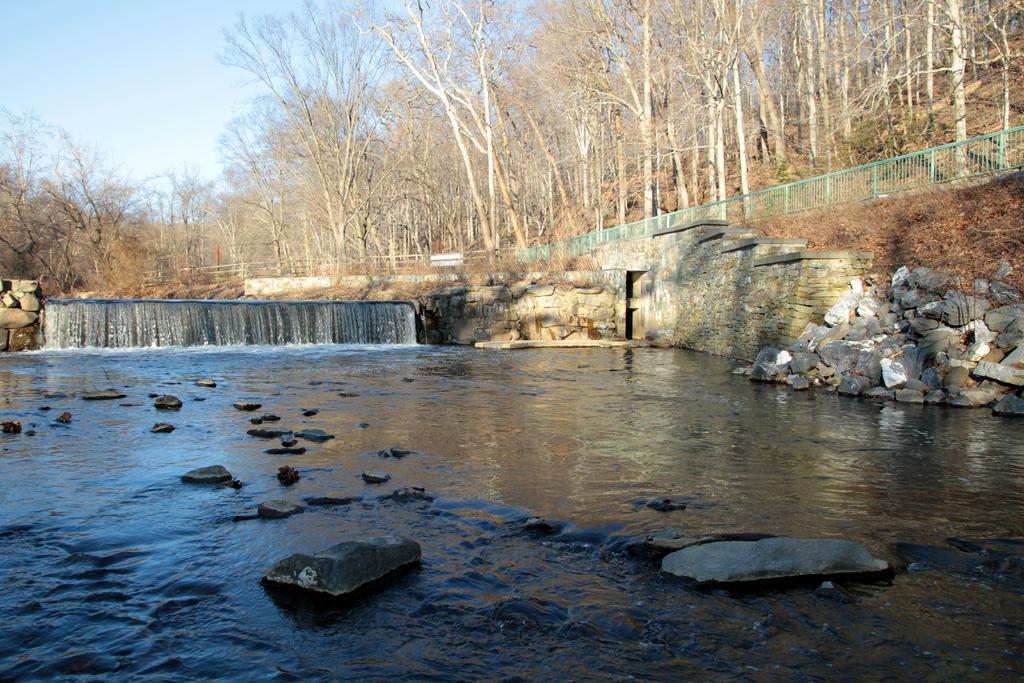In one or two sentences, can you explain what this image depicts? In this image we can see sky, trees, hills, grill, waterfall, walls, running water and stones. 